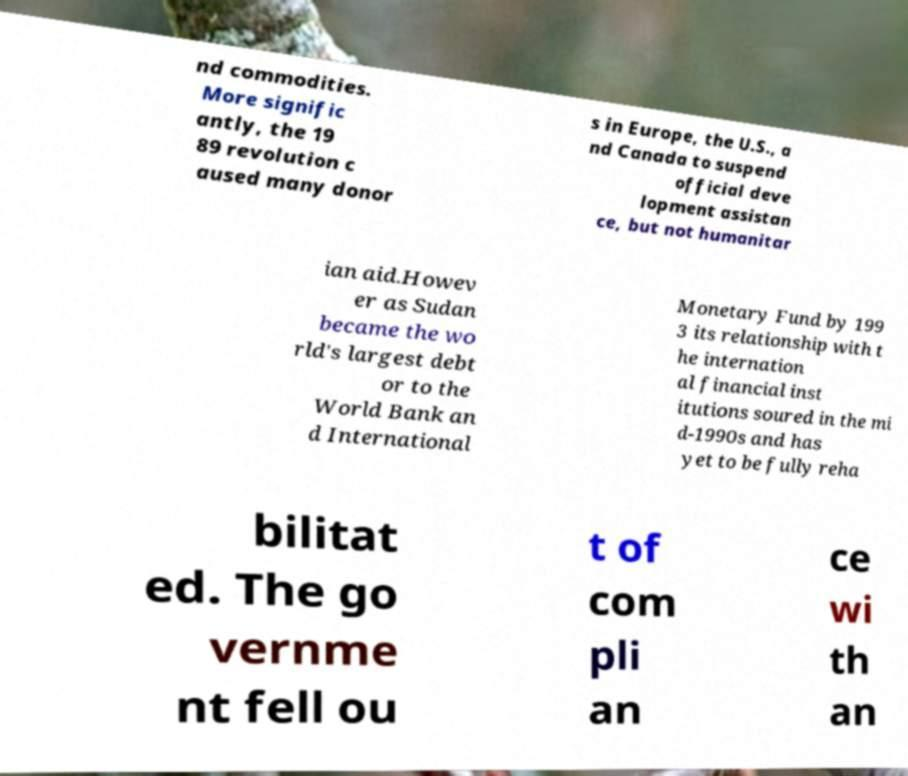I need the written content from this picture converted into text. Can you do that? nd commodities. More signific antly, the 19 89 revolution c aused many donor s in Europe, the U.S., a nd Canada to suspend official deve lopment assistan ce, but not humanitar ian aid.Howev er as Sudan became the wo rld's largest debt or to the World Bank an d International Monetary Fund by 199 3 its relationship with t he internation al financial inst itutions soured in the mi d-1990s and has yet to be fully reha bilitat ed. The go vernme nt fell ou t of com pli an ce wi th an 